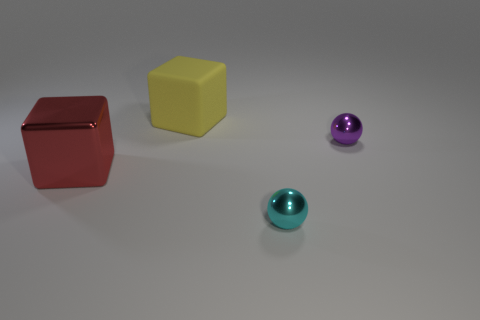How many things are things in front of the yellow object or large rubber things?
Offer a terse response. 4. Is the big red block made of the same material as the cyan object?
Make the answer very short. Yes. There is a yellow object that is the same shape as the red metallic object; what size is it?
Make the answer very short. Large. There is a small object right of the cyan thing; is it the same shape as the large object left of the yellow thing?
Make the answer very short. No. Is the size of the rubber block the same as the ball that is in front of the large shiny object?
Make the answer very short. No. How many other things are there of the same material as the yellow cube?
Keep it short and to the point. 0. Is there anything else that has the same shape as the big red thing?
Provide a short and direct response. Yes. What is the color of the metallic thing to the left of the tiny sphere in front of the object that is to the right of the tiny cyan shiny sphere?
Offer a terse response. Red. What shape is the shiny thing that is both on the right side of the matte object and on the left side of the tiny purple shiny sphere?
Your answer should be compact. Sphere. Is there any other thing that is the same size as the red block?
Your response must be concise. Yes. 